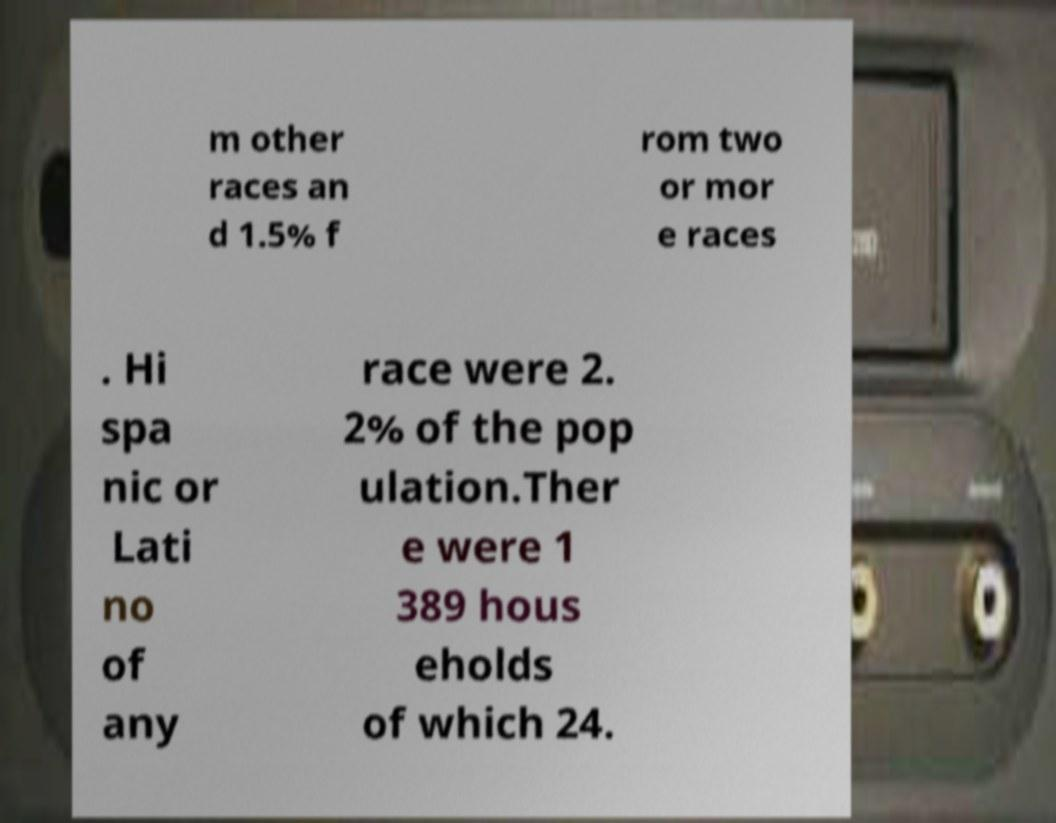What messages or text are displayed in this image? I need them in a readable, typed format. m other races an d 1.5% f rom two or mor e races . Hi spa nic or Lati no of any race were 2. 2% of the pop ulation.Ther e were 1 389 hous eholds of which 24. 